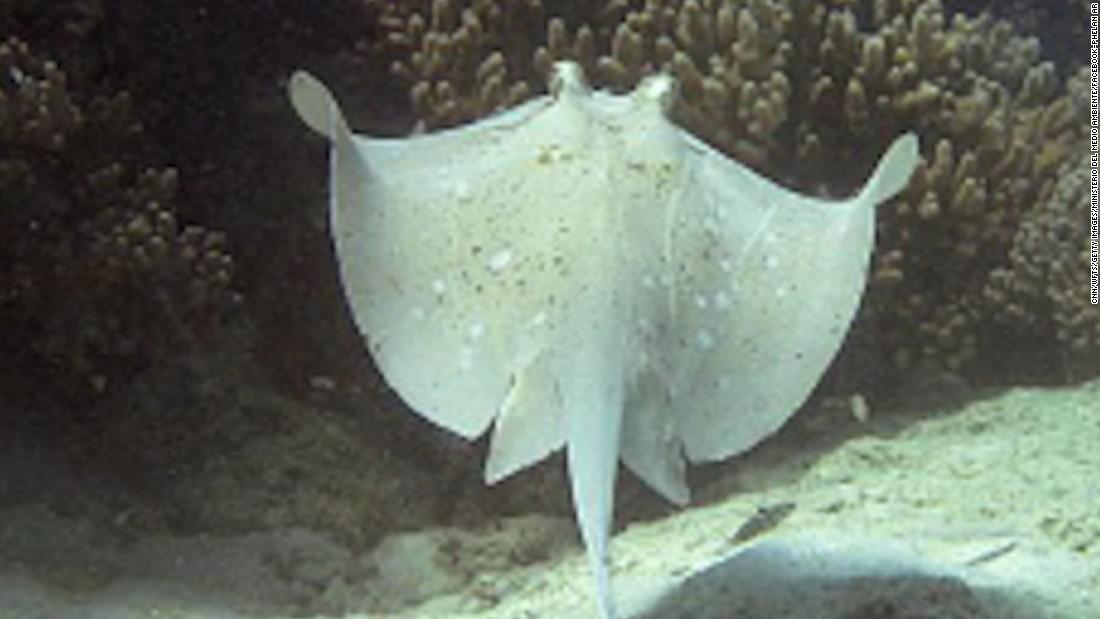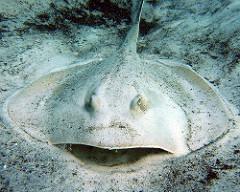The first image is the image on the left, the second image is the image on the right. Given the left and right images, does the statement "An image shows one dark stingray with small pale dots." hold true? Answer yes or no. No. 